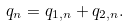<formula> <loc_0><loc_0><loc_500><loc_500>q _ { n } = q _ { 1 , n } + q _ { 2 , n } .</formula> 